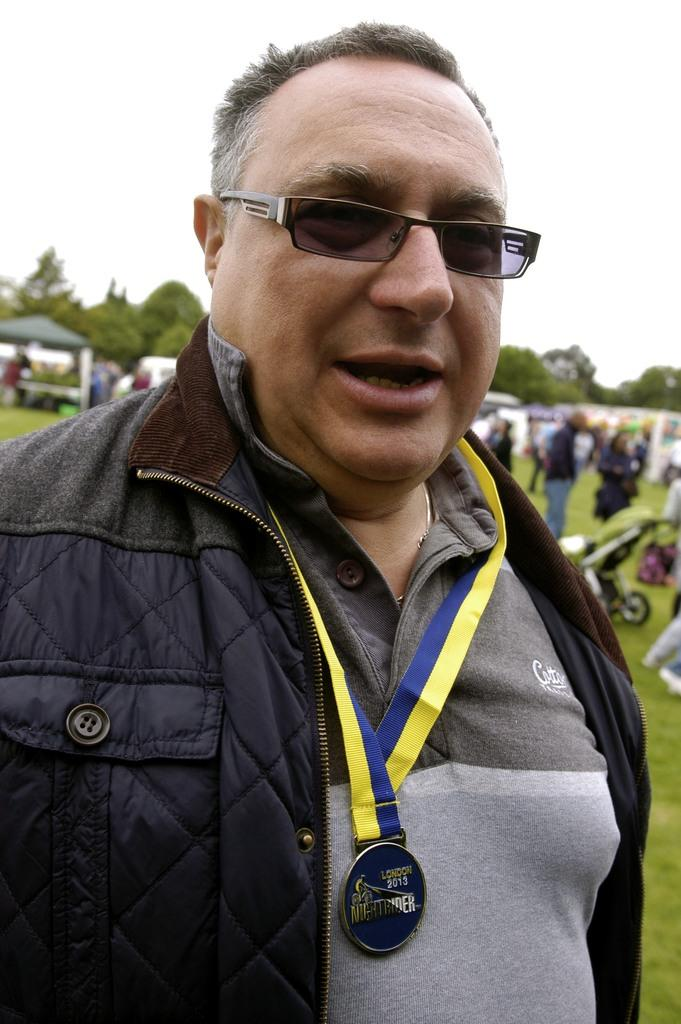Who is the main subject in the image? There is a man in the center of the image. What is the man wearing in the image? The man is wearing glasses in the image. What can be seen in the background of the image? There are people, stalls, grassland, trees, and the sky visible in the background of the image. What type of humor can be seen in the image? There is no humor depicted in the image; it is a scene with a man, glasses, and a background with people, stalls, grassland, trees, and the sky. How many chairs are visible in the image? There are no chairs visible in the image. 